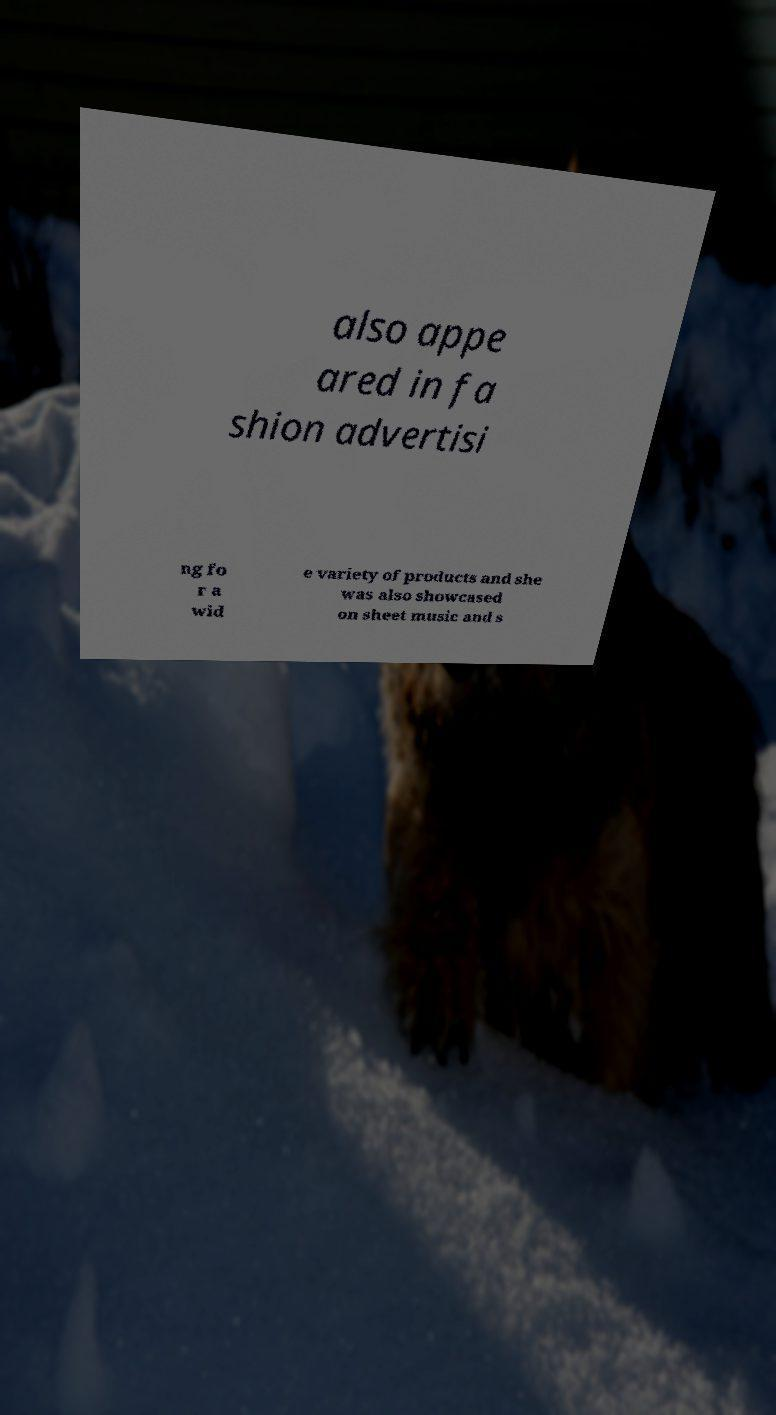Could you assist in decoding the text presented in this image and type it out clearly? also appe ared in fa shion advertisi ng fo r a wid e variety of products and she was also showcased on sheet music and s 